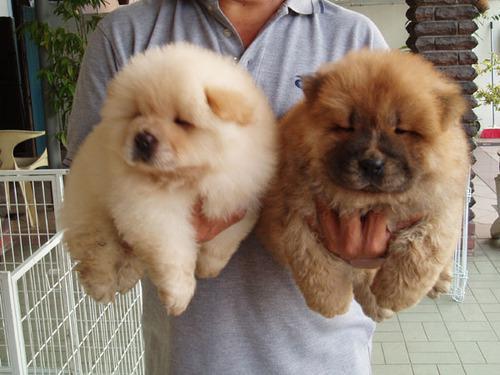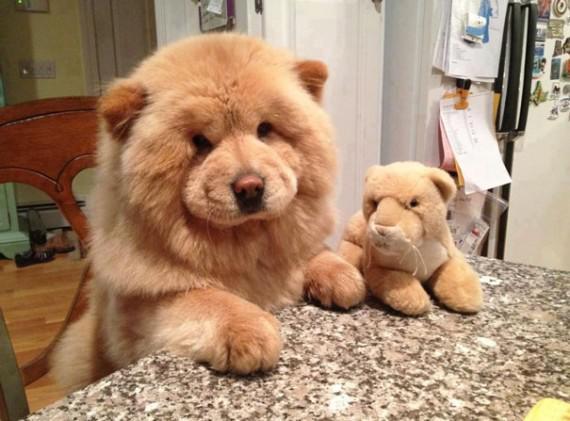The first image is the image on the left, the second image is the image on the right. For the images displayed, is the sentence "One of the images contains at least four dogs." factually correct? Answer yes or no. No. 